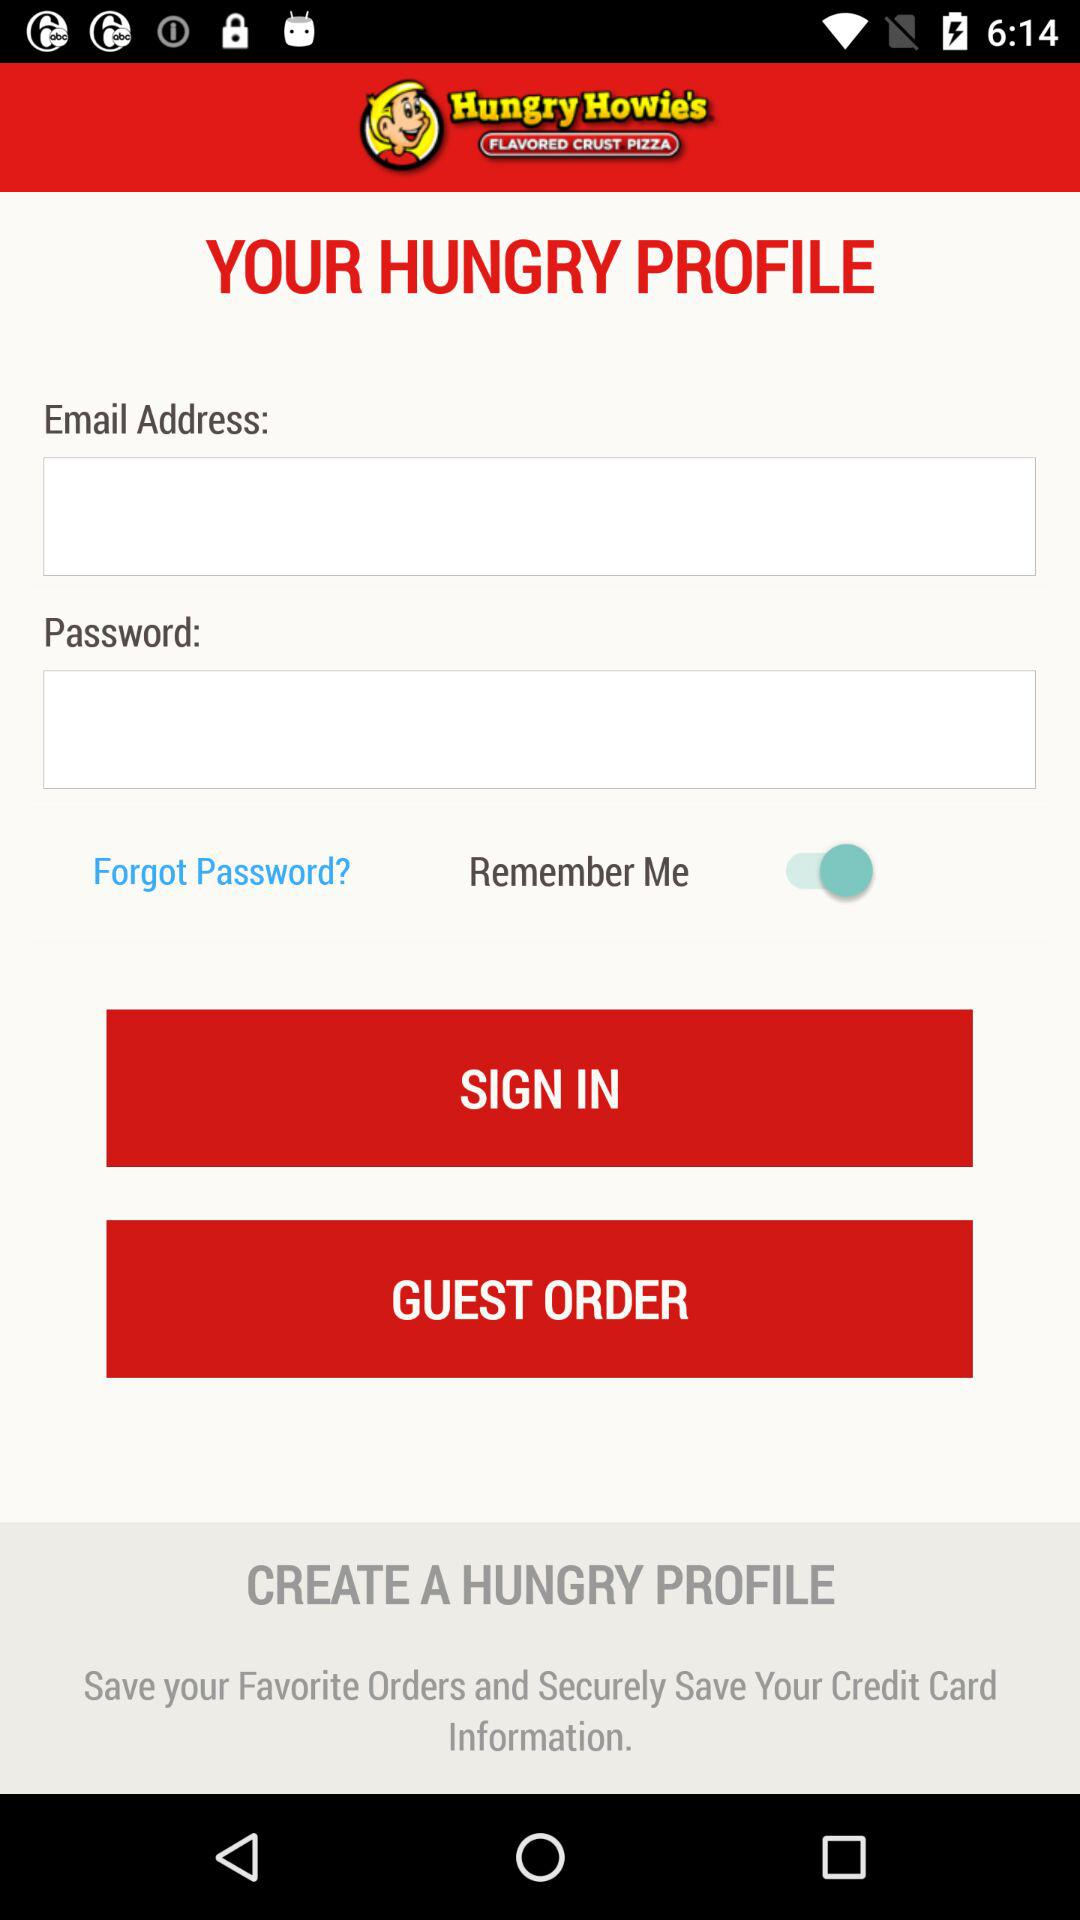How many text inputs are there for sign in?
Answer the question using a single word or phrase. 2 